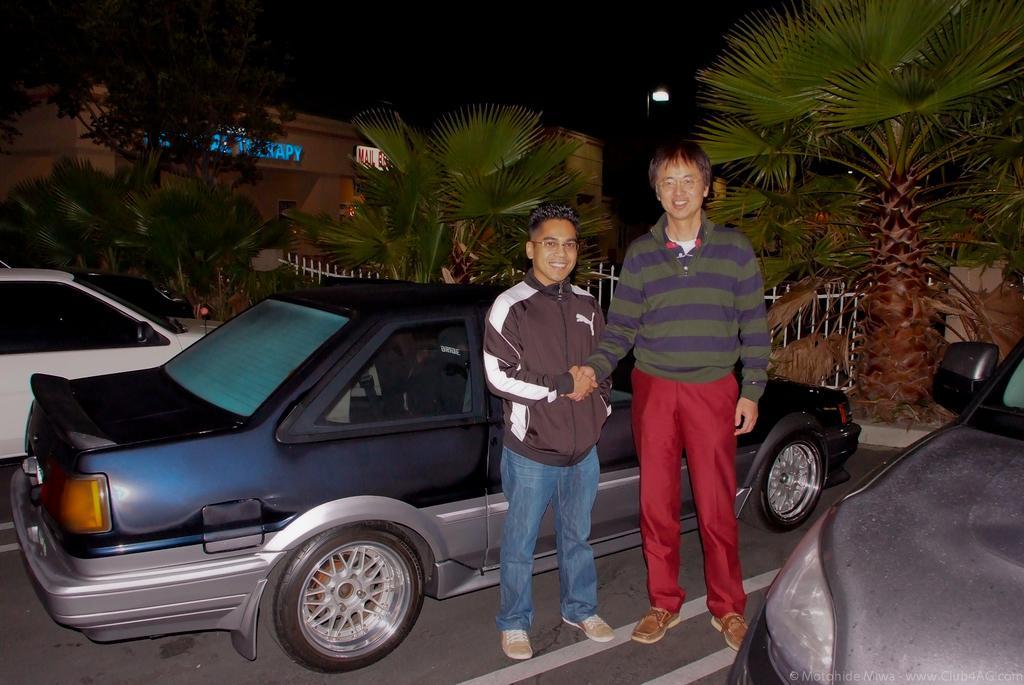Please provide a concise description of this image. In this image in the center there are persons standing and smiling and shaking hands with each other, there are vehicles. In the background there are trees, there is a building and on the building there is some text written on it and there is a light pole and there is a fence which is white in colour. 